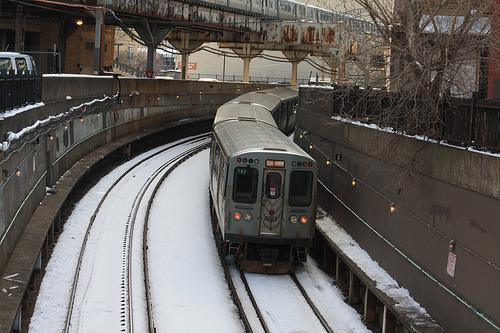Question: how many people are in the photo?
Choices:
A. One.
B. Three.
C. Five.
D. Zero.
Answer with the letter. Answer: D Question: what color is the train?
Choices:
A. Red.
B. Blue.
C. White.
D. Grey.
Answer with the letter. Answer: D Question: who is standing next to the train?
Choices:
A. No one.
B. One person.
C. Two people.
D. Three people.
Answer with the letter. Answer: A 